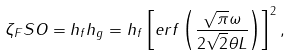Convert formula to latex. <formula><loc_0><loc_0><loc_500><loc_500>\zeta _ { F } S O = h _ { f } h _ { g } = h _ { f } \left [ e r f \left ( \frac { \sqrt { \pi } \omega } { 2 \sqrt { 2 } \theta L } \right ) \right ] ^ { 2 } ,</formula> 